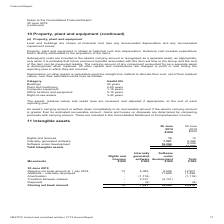From Nextdc's financial document, What were the 3 types of intangible assets? The document contains multiple relevant values: Rights and licences, Internally generated software, Software under development. From the document: "Rights and licences 13 13 Internally generated software 7,381 6,385 Software under development 16,284 6,509 Total intangible assets 23,678 12,907 Righ..." Also, What was the total opening net book amount at 1 July 2018? According to the financial document, 12,907 (in thousands). The relevant text states: "ing net book amount at 1 July 2018 13 6,385 6,509 12,907 Additions – internally developed - - 11,896 11,896 Amortisation - (1,116) - (1,116) Transfers betwe..." Also, What was the total closing net book account at 30 June 2019? According to the financial document, 23,678 (in thousands). The relevant text states: "(9) - (9) Closing net book amount 13 7,381 16,284 23,678..." Also, can you calculate: What was the difference between total opening and closing net book amount? Based on the calculation: 23,678 - 12,907 , the result is 10771 (in thousands). This is based on the information: "(9) - (9) Closing net book amount 13 7,381 16,284 23,678 ing net book amount at 1 July 2018 13 6,385 6,509 12,907 Additions – internally developed - - 11,896 11,896 Amortisation - (1,116) - (1,116) Tr..." The key data points involved are: 12,907, 23,678. Also, can you calculate: What was the change in net book amount for software under development between 2018 and 2019? Based on the calculation: 16,284 - 6,509 , the result is 9775 (in thousands). This is based on the information: "9 Opening net book amount at 1 July 2018 13 6,385 6,509 12,907 Additions – internally developed - - 11,896 11,896 Amortisation - (1,116) - (1,116) Transfer sals - (9) - (9) Closing net book amount 13 ..." The key data points involved are: 16,284, 6,509. Also, can you calculate: What percentage of the total gain in book amount was due to internally generated software? To answer this question, I need to perform calculations using the financial data. The calculation is: (7,381 - 6,385) / (23,678 - 12,907) , which equals 9.25 (percentage). This is based on the information: "ne 2019 Opening net book amount at 1 July 2018 13 6,385 6,509 12,907 Additions – internally developed - - 11,896 11,896 Amortisation - (1,116) - (1,116) Tr (9) - (9) Closing net book amount 13 7,381 1..." The key data points involved are: 12,907, 23,678, 6,385. 